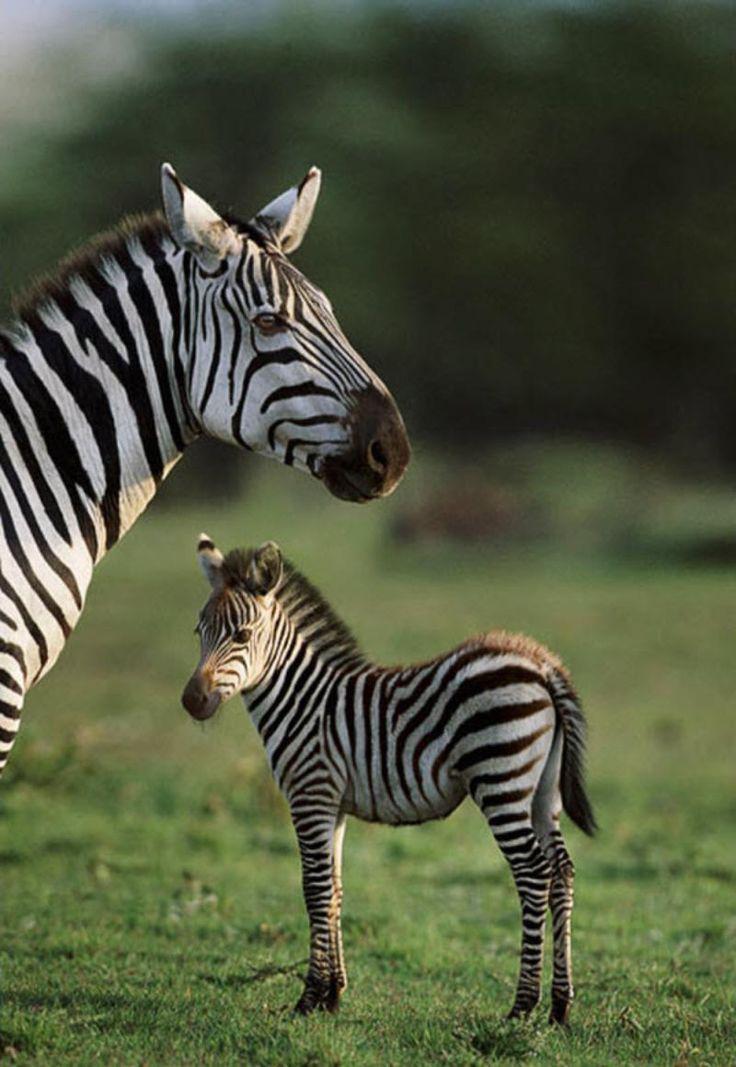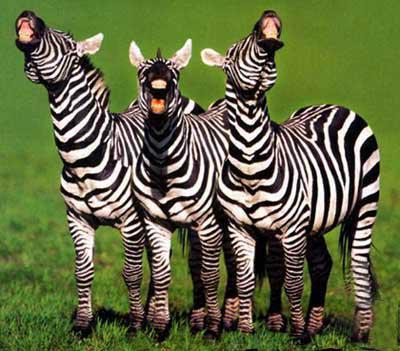The first image is the image on the left, the second image is the image on the right. For the images shown, is this caption "All zebras are showing their teeth as if braying, and at least one image features two zebras side-by-side." true? Answer yes or no. No. The first image is the image on the left, the second image is the image on the right. Considering the images on both sides, is "There are at least four zebras in total." valid? Answer yes or no. Yes. 